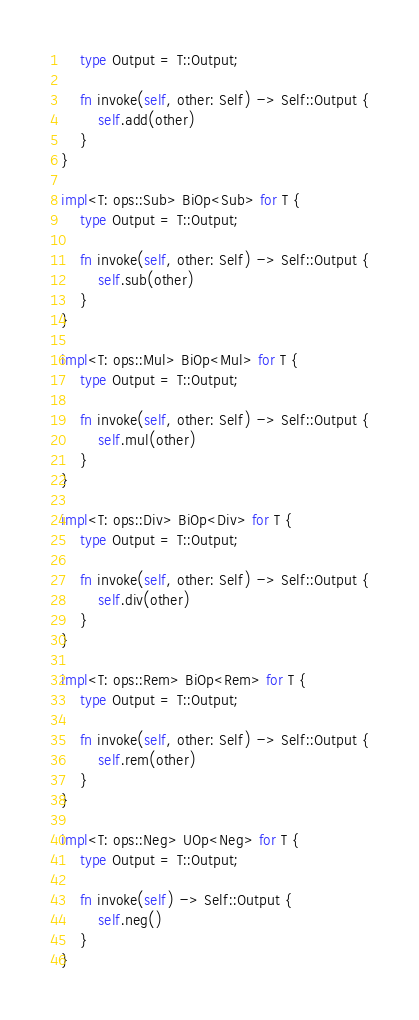Convert code to text. <code><loc_0><loc_0><loc_500><loc_500><_Rust_>    type Output = T::Output;

    fn invoke(self, other: Self) -> Self::Output {
        self.add(other)
    }
}

impl<T: ops::Sub> BiOp<Sub> for T {
    type Output = T::Output;

    fn invoke(self, other: Self) -> Self::Output {
        self.sub(other)
    }
}

impl<T: ops::Mul> BiOp<Mul> for T {
    type Output = T::Output;

    fn invoke(self, other: Self) -> Self::Output {
        self.mul(other)
    }
}

impl<T: ops::Div> BiOp<Div> for T {
    type Output = T::Output;

    fn invoke(self, other: Self) -> Self::Output {
        self.div(other)
    }
}

impl<T: ops::Rem> BiOp<Rem> for T {
    type Output = T::Output;

    fn invoke(self, other: Self) -> Self::Output {
        self.rem(other)
    }
}

impl<T: ops::Neg> UOp<Neg> for T {
    type Output = T::Output;

    fn invoke(self) -> Self::Output {
        self.neg()
    }
}
</code> 